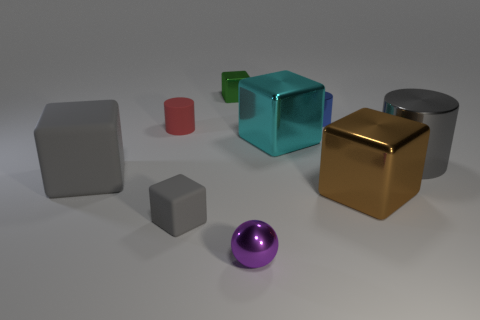Is the number of large shiny blocks left of the small metal block the same as the number of cubes?
Offer a very short reply. No. What shape is the gray shiny thing that is the same size as the cyan metallic block?
Offer a very short reply. Cylinder. Are there any cyan things that are in front of the big metallic object that is in front of the large cylinder?
Provide a short and direct response. No. How many large things are either blue cylinders or green blocks?
Make the answer very short. 0. Are there any blue cylinders that have the same size as the brown object?
Your answer should be very brief. No. What number of metal objects are large gray things or tiny cylinders?
Keep it short and to the point. 2. There is a large thing that is the same color as the large matte block; what shape is it?
Your response must be concise. Cylinder. How many small brown matte objects are there?
Your answer should be compact. 0. Is the material of the large cube that is behind the big gray cube the same as the small ball that is on the left side of the large cylinder?
Your answer should be very brief. Yes. What is the size of the green block that is the same material as the blue object?
Offer a very short reply. Small. 